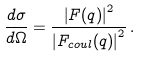<formula> <loc_0><loc_0><loc_500><loc_500>\frac { d \sigma } { d \Omega } = \frac { \left | F ( q ) \right | ^ { 2 } } { \left | F _ { c o u l } ( q ) \right | ^ { 2 } } \, .</formula> 